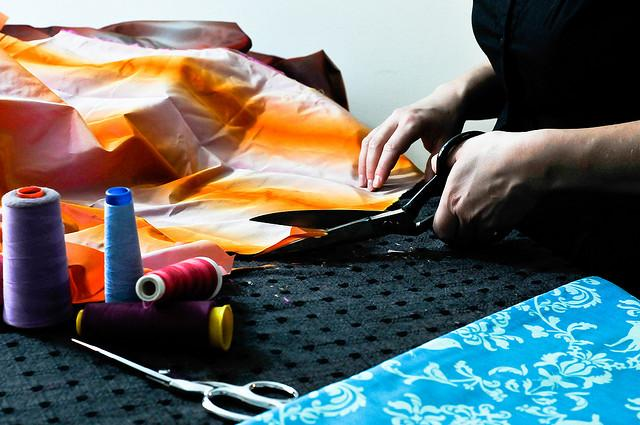What item does the person cut? Please explain your reasoning. cloth. The item is for cloth. 